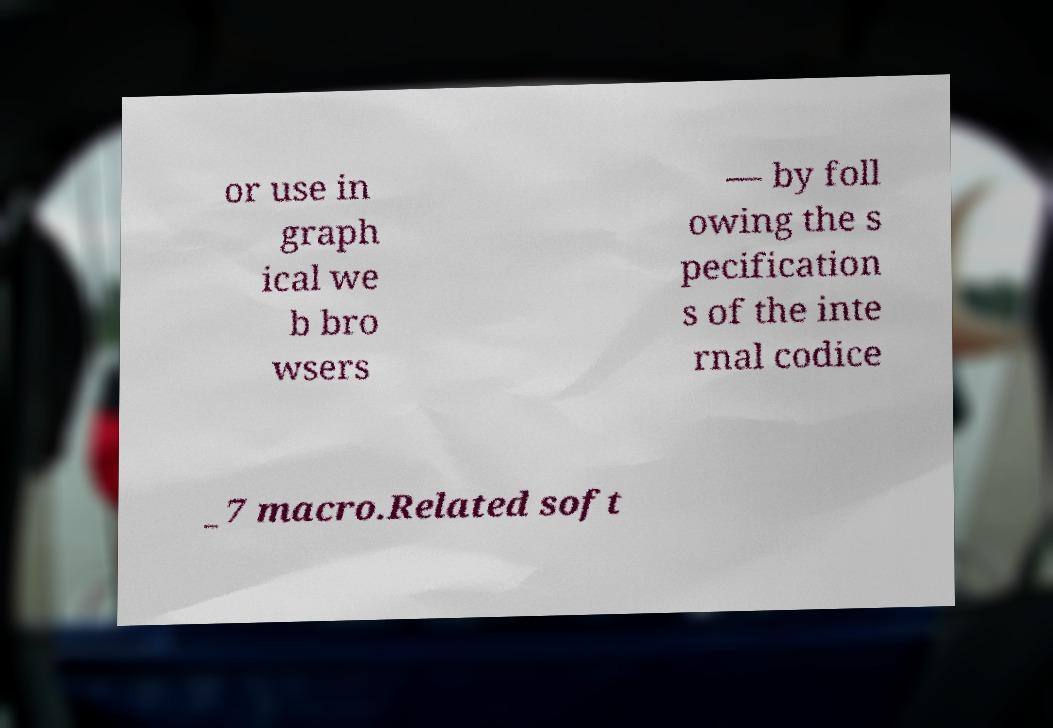I need the written content from this picture converted into text. Can you do that? or use in graph ical we b bro wsers — by foll owing the s pecification s of the inte rnal codice _7 macro.Related soft 